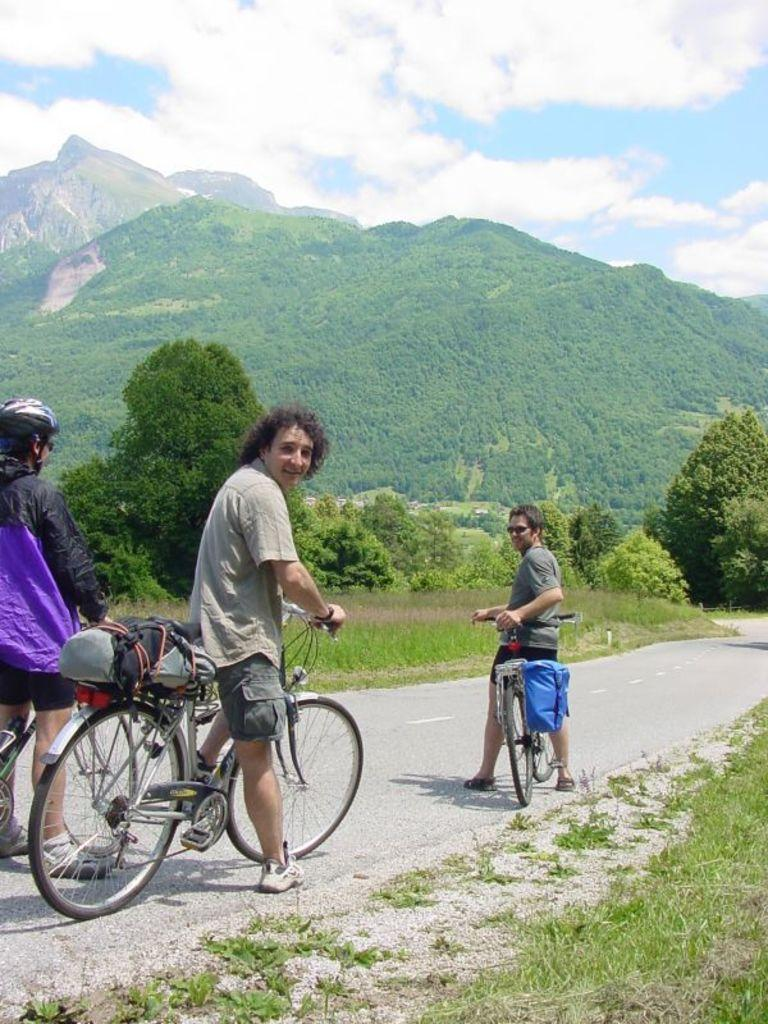What is the person in the image holding? The person is holding a bicycle in the image. What type of natural environment is visible in the image? There are trees and mountains in the image. What industry is depicted in the image? There is no industry present in the image; it features a person holding a bicycle, trees, and mountains. How many words can be seen written on the person's shirt in the image? There is no text visible on the person's shirt in the image. 